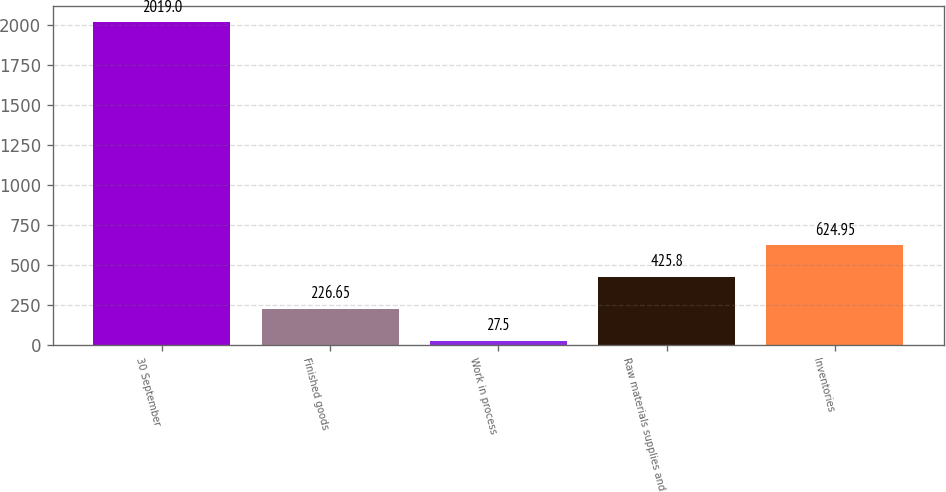Convert chart. <chart><loc_0><loc_0><loc_500><loc_500><bar_chart><fcel>30 September<fcel>Finished goods<fcel>Work in process<fcel>Raw materials supplies and<fcel>Inventories<nl><fcel>2019<fcel>226.65<fcel>27.5<fcel>425.8<fcel>624.95<nl></chart> 